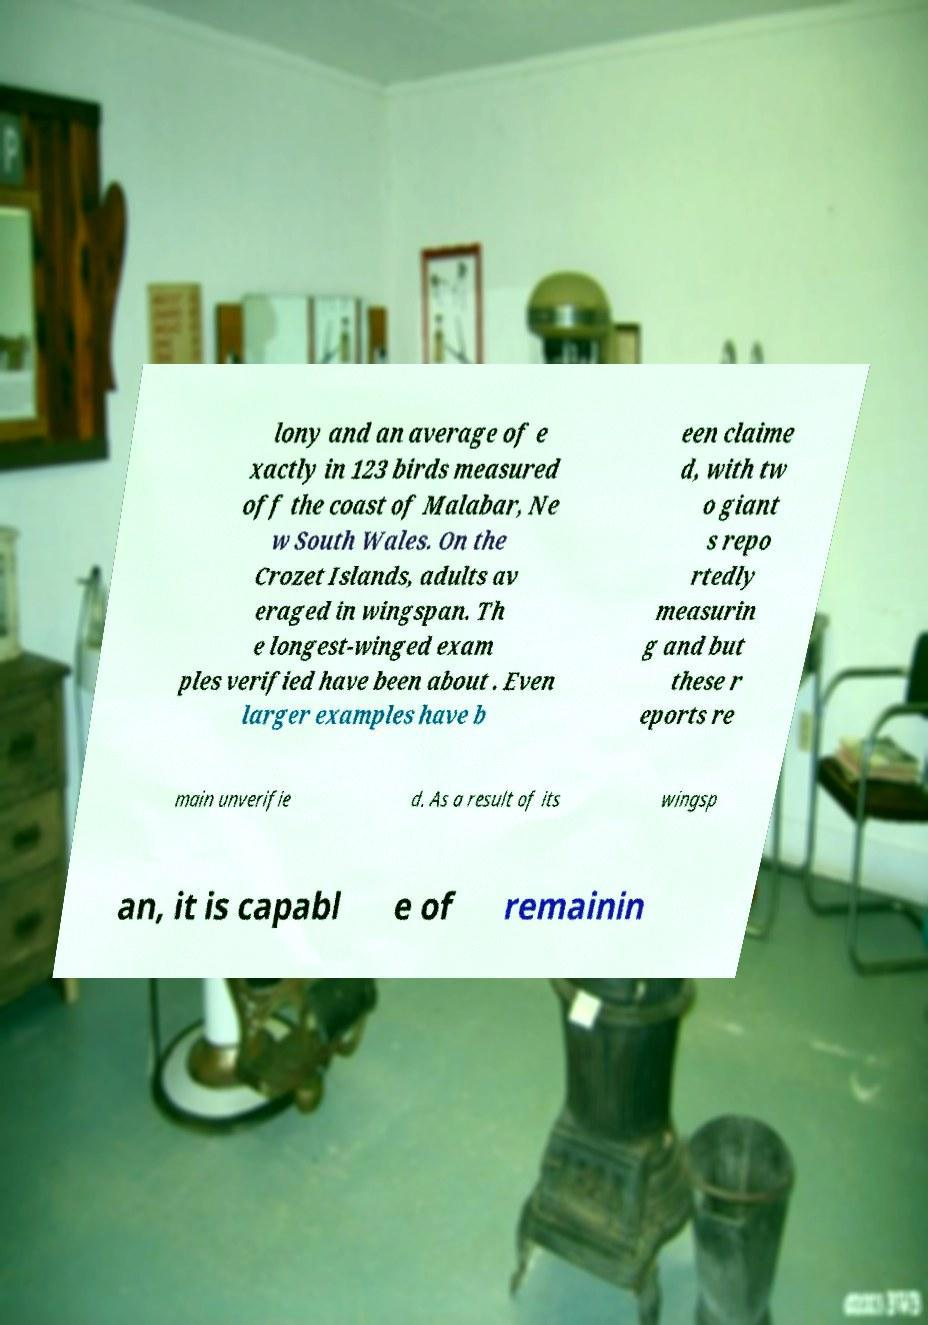Can you accurately transcribe the text from the provided image for me? lony and an average of e xactly in 123 birds measured off the coast of Malabar, Ne w South Wales. On the Crozet Islands, adults av eraged in wingspan. Th e longest-winged exam ples verified have been about . Even larger examples have b een claime d, with tw o giant s repo rtedly measurin g and but these r eports re main unverifie d. As a result of its wingsp an, it is capabl e of remainin 